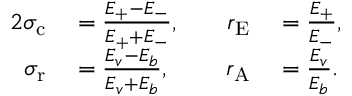<formula> <loc_0><loc_0><loc_500><loc_500>\begin{array} { r l r l } { { 2 } \sigma _ { c } } & = \frac { E _ { + } - E _ { - } } { E _ { + } + E _ { - } } , \quad } & { r _ { E } } & = \frac { E _ { + } } { E _ { - } } , } \\ { \sigma _ { r } } & = \frac { E _ { v } - E _ { b } } { E _ { v } + E _ { b } } , } & { r _ { A } } & = \frac { E _ { v } } { E _ { b } } . } \end{array}</formula> 